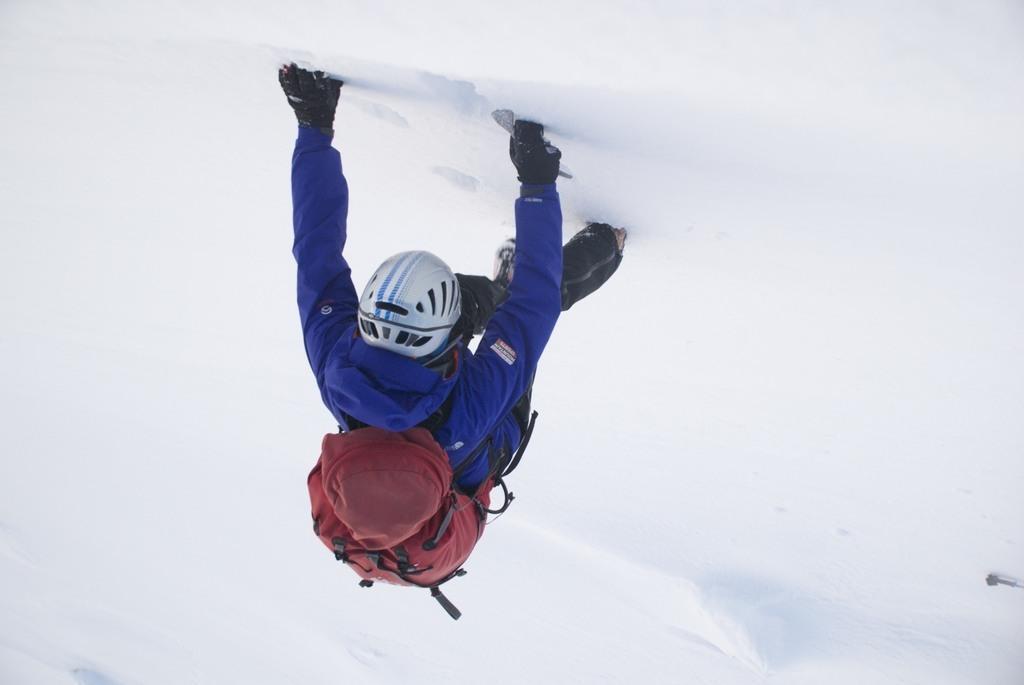Please provide a concise description of this image. In this image, there is a person wearing clothes, bag, helmet and gloves. I think this person is walking on the snow. 